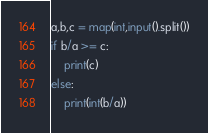<code> <loc_0><loc_0><loc_500><loc_500><_Python_>a,b,c = map(int,input().split())
if b/a >= c:
    print(c)
else:
    print(int(b/a))</code> 